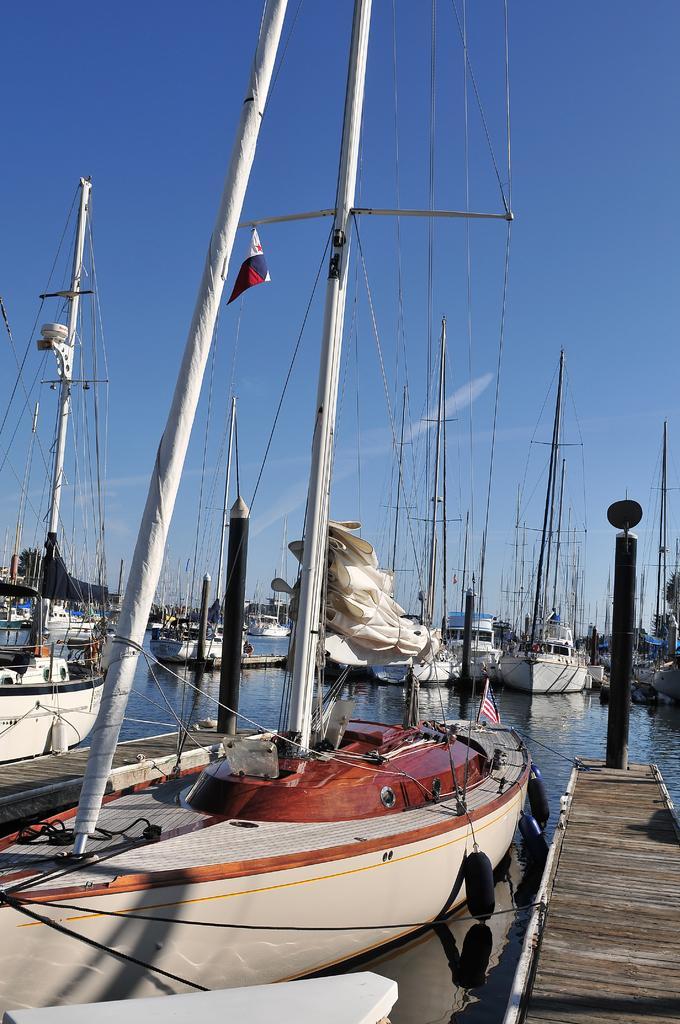Please provide a concise description of this image. In this image there are boats in the center and on the boats there are poles, ropes, and on the right side there is a ramp and a black colour pole. 